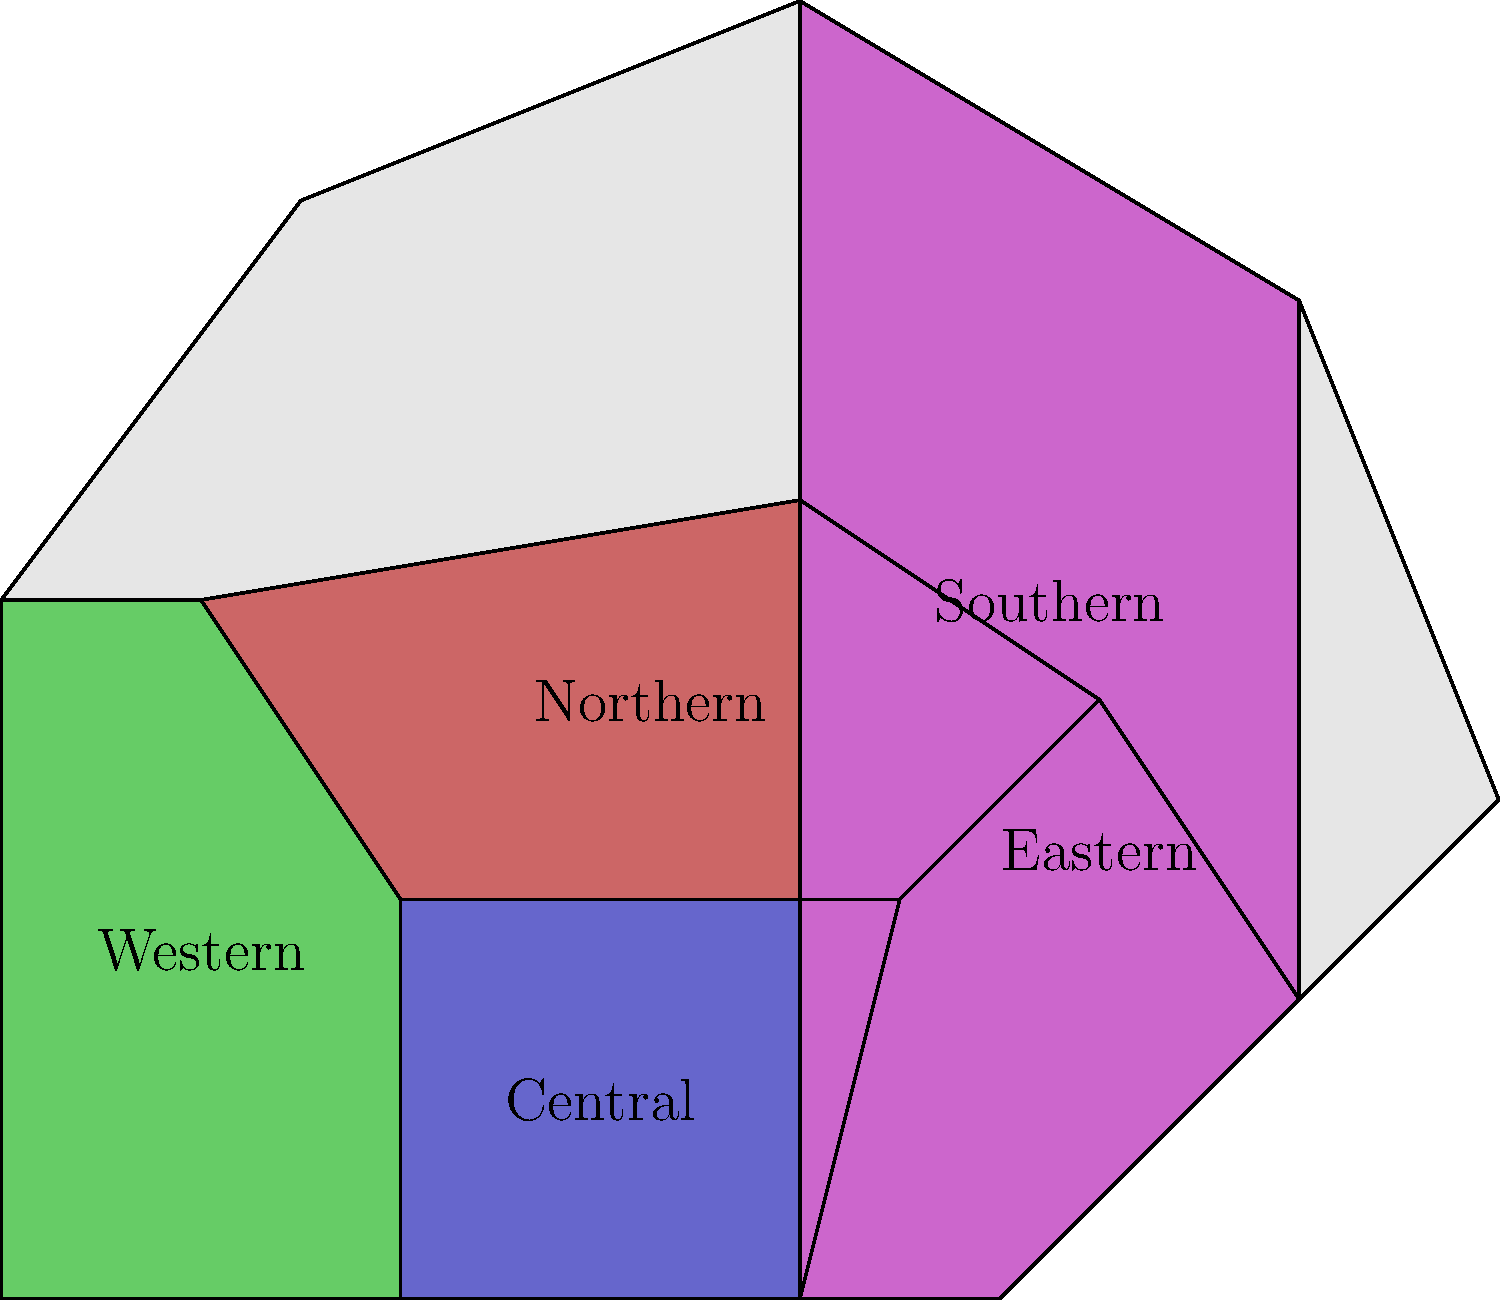Based on the map of African Union regions, which region shares borders with all other regions and is most strategically positioned for coordinating continent-wide human rights initiatives? To answer this question, we need to analyze the map and consider the geographical relationships between the regions:

1. Identify all regions: Northern, Western, Central, Eastern, and Southern.

2. Examine each region's borders:
   - Northern: borders Western, Central, and Eastern
   - Western: borders Northern and Central
   - Central: borders Northern, Western, Eastern, and Southern
   - Eastern: borders Northern, Central, and Southern
   - Southern: borders Central and Eastern

3. Determine which region shares borders with all others:
   Central is the only region that borders all other regions (Northern, Western, Eastern, and Southern).

4. Consider the strategic position:
   The Central region's position allows for direct communication and coordination with all other regions, making it ideal for continent-wide initiatives.

5. Relate to human rights initiatives:
   For a human rights lawyer working on African Union accountability, the Central region would be most strategically positioned to coordinate efforts, gather information, and implement continent-wide strategies.
Answer: Central region 